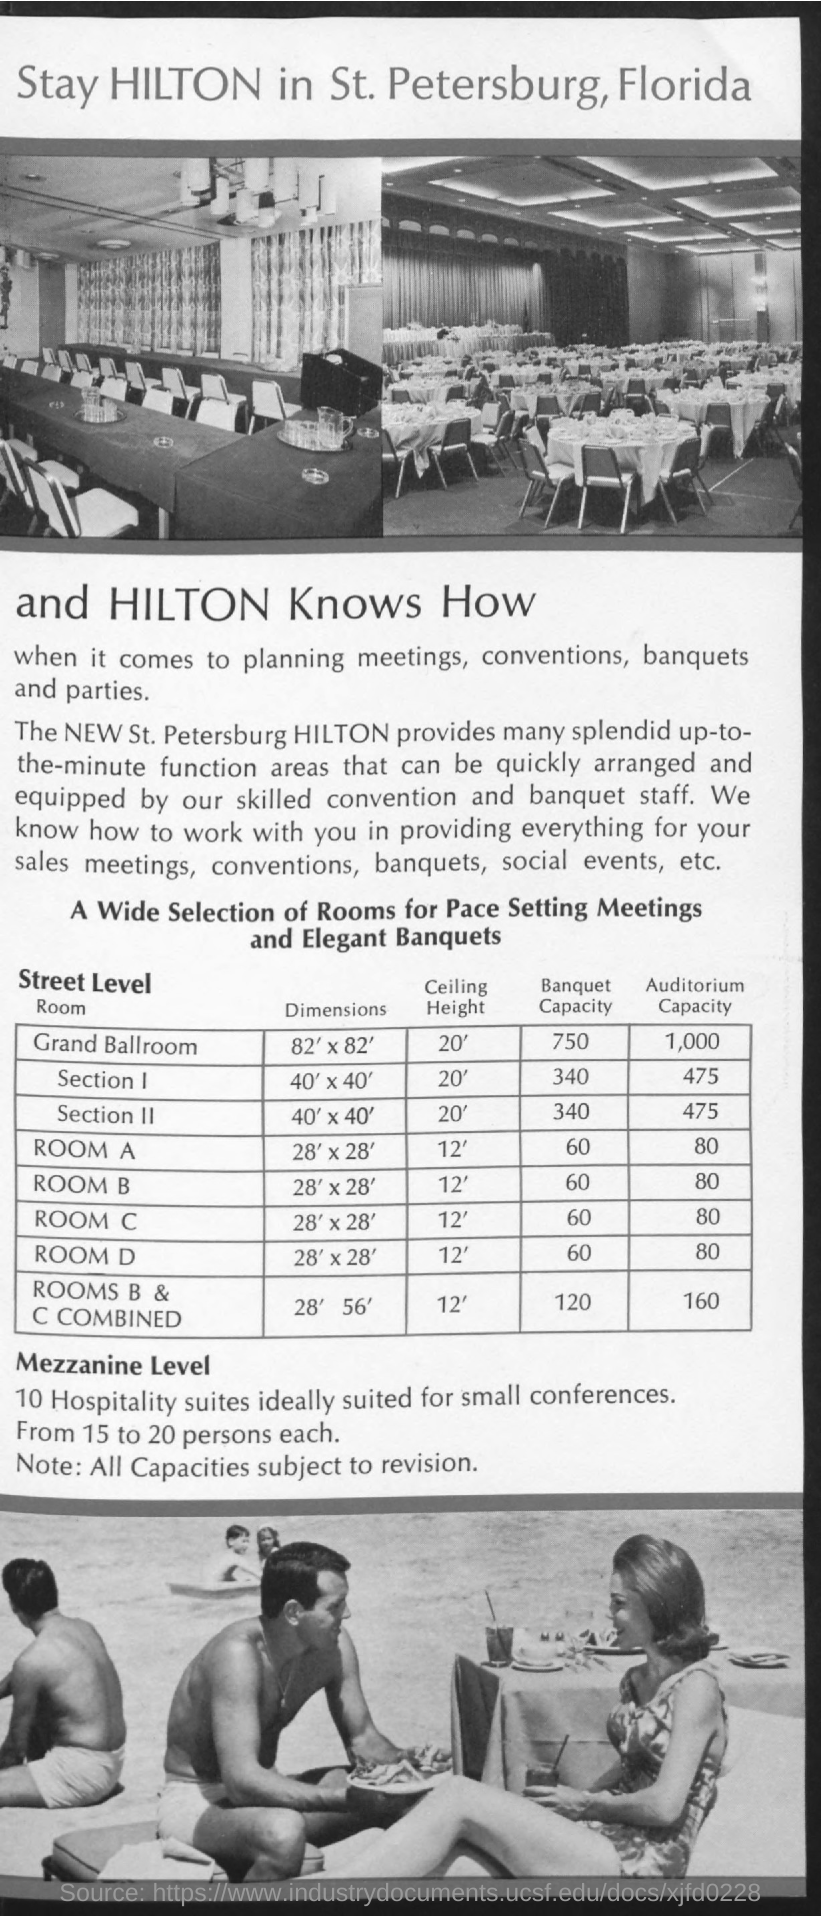what is the auditorium capacity of Room A? The auditorium capacity of Room A at the St. Petersburg Hilton is 80 people, as noted in the provided materials. This room size and capacity make it suitable for mid-sized events such as seminars, workshops, or presentations. 